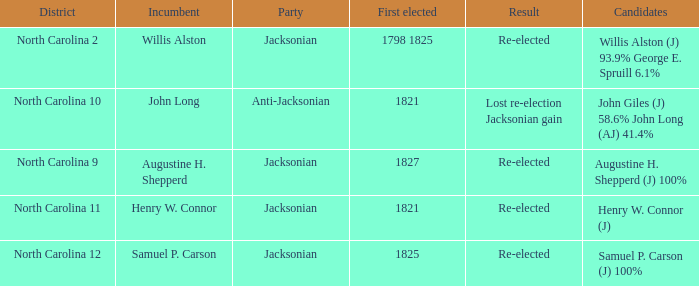Name the result for first elected being 1798 1825 Re-elected. 